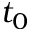Convert formula to latex. <formula><loc_0><loc_0><loc_500><loc_500>t _ { 0 }</formula> 